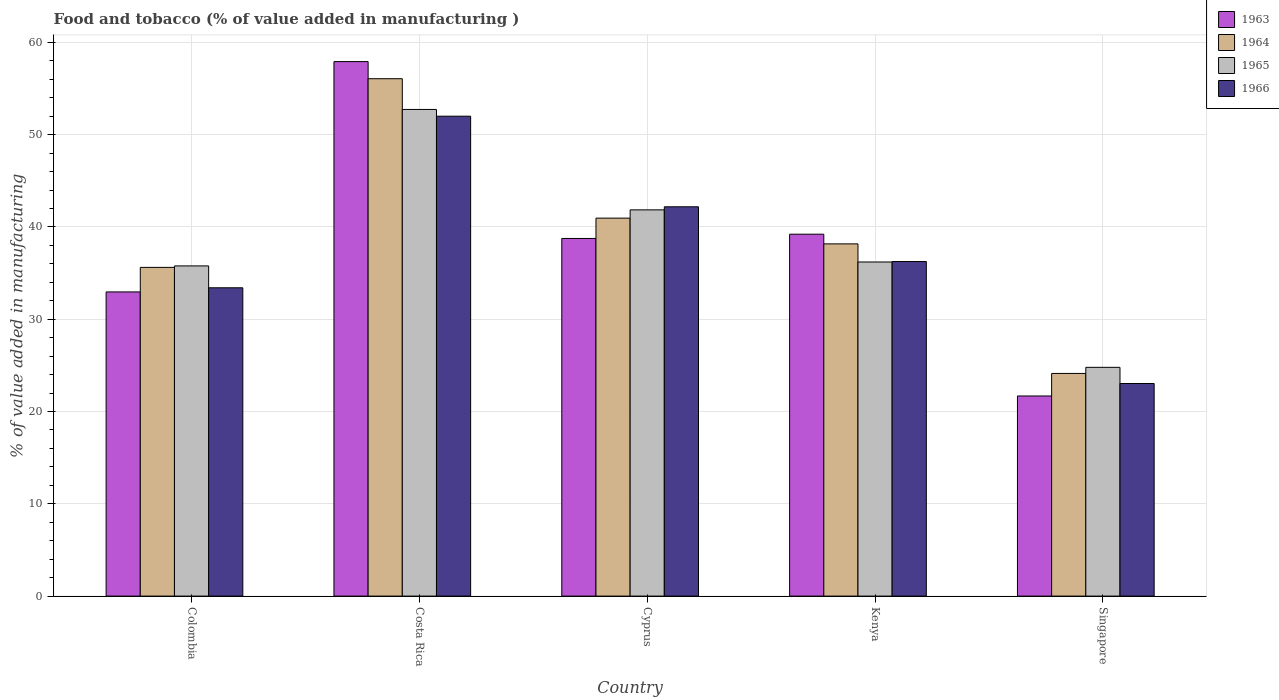How many different coloured bars are there?
Your answer should be very brief. 4. How many groups of bars are there?
Your answer should be compact. 5. Are the number of bars per tick equal to the number of legend labels?
Offer a terse response. Yes. How many bars are there on the 2nd tick from the left?
Offer a terse response. 4. What is the label of the 4th group of bars from the left?
Give a very brief answer. Kenya. In how many cases, is the number of bars for a given country not equal to the number of legend labels?
Offer a terse response. 0. What is the value added in manufacturing food and tobacco in 1963 in Singapore?
Offer a very short reply. 21.69. Across all countries, what is the maximum value added in manufacturing food and tobacco in 1964?
Ensure brevity in your answer.  56.07. Across all countries, what is the minimum value added in manufacturing food and tobacco in 1966?
Keep it short and to the point. 23.04. In which country was the value added in manufacturing food and tobacco in 1963 maximum?
Provide a succinct answer. Costa Rica. In which country was the value added in manufacturing food and tobacco in 1964 minimum?
Offer a terse response. Singapore. What is the total value added in manufacturing food and tobacco in 1966 in the graph?
Make the answer very short. 186.89. What is the difference between the value added in manufacturing food and tobacco in 1963 in Cyprus and that in Kenya?
Provide a short and direct response. -0.46. What is the difference between the value added in manufacturing food and tobacco in 1964 in Costa Rica and the value added in manufacturing food and tobacco in 1963 in Colombia?
Keep it short and to the point. 23.11. What is the average value added in manufacturing food and tobacco in 1966 per country?
Keep it short and to the point. 37.38. What is the difference between the value added in manufacturing food and tobacco of/in 1966 and value added in manufacturing food and tobacco of/in 1963 in Colombia?
Make the answer very short. 0.45. What is the ratio of the value added in manufacturing food and tobacco in 1964 in Colombia to that in Costa Rica?
Your response must be concise. 0.64. Is the value added in manufacturing food and tobacco in 1965 in Kenya less than that in Singapore?
Give a very brief answer. No. Is the difference between the value added in manufacturing food and tobacco in 1966 in Colombia and Singapore greater than the difference between the value added in manufacturing food and tobacco in 1963 in Colombia and Singapore?
Ensure brevity in your answer.  No. What is the difference between the highest and the second highest value added in manufacturing food and tobacco in 1964?
Provide a succinct answer. 15.11. What is the difference between the highest and the lowest value added in manufacturing food and tobacco in 1964?
Your answer should be compact. 31.94. In how many countries, is the value added in manufacturing food and tobacco in 1963 greater than the average value added in manufacturing food and tobacco in 1963 taken over all countries?
Ensure brevity in your answer.  3. Is the sum of the value added in manufacturing food and tobacco in 1965 in Colombia and Kenya greater than the maximum value added in manufacturing food and tobacco in 1966 across all countries?
Your answer should be very brief. Yes. Is it the case that in every country, the sum of the value added in manufacturing food and tobacco in 1966 and value added in manufacturing food and tobacco in 1963 is greater than the sum of value added in manufacturing food and tobacco in 1965 and value added in manufacturing food and tobacco in 1964?
Your response must be concise. No. What does the 4th bar from the left in Kenya represents?
Your answer should be very brief. 1966. What does the 1st bar from the right in Kenya represents?
Give a very brief answer. 1966. Is it the case that in every country, the sum of the value added in manufacturing food and tobacco in 1963 and value added in manufacturing food and tobacco in 1964 is greater than the value added in manufacturing food and tobacco in 1965?
Offer a very short reply. Yes. How many bars are there?
Keep it short and to the point. 20. Are all the bars in the graph horizontal?
Offer a very short reply. No. How many countries are there in the graph?
Offer a terse response. 5. Are the values on the major ticks of Y-axis written in scientific E-notation?
Your answer should be compact. No. Does the graph contain grids?
Ensure brevity in your answer.  Yes. How many legend labels are there?
Your answer should be compact. 4. What is the title of the graph?
Offer a terse response. Food and tobacco (% of value added in manufacturing ). Does "1962" appear as one of the legend labels in the graph?
Provide a short and direct response. No. What is the label or title of the Y-axis?
Give a very brief answer. % of value added in manufacturing. What is the % of value added in manufacturing of 1963 in Colombia?
Ensure brevity in your answer.  32.96. What is the % of value added in manufacturing of 1964 in Colombia?
Give a very brief answer. 35.62. What is the % of value added in manufacturing in 1965 in Colombia?
Make the answer very short. 35.78. What is the % of value added in manufacturing in 1966 in Colombia?
Provide a succinct answer. 33.41. What is the % of value added in manufacturing in 1963 in Costa Rica?
Offer a terse response. 57.92. What is the % of value added in manufacturing in 1964 in Costa Rica?
Keep it short and to the point. 56.07. What is the % of value added in manufacturing of 1965 in Costa Rica?
Make the answer very short. 52.73. What is the % of value added in manufacturing in 1966 in Costa Rica?
Make the answer very short. 52. What is the % of value added in manufacturing in 1963 in Cyprus?
Your answer should be very brief. 38.75. What is the % of value added in manufacturing of 1964 in Cyprus?
Your answer should be very brief. 40.96. What is the % of value added in manufacturing of 1965 in Cyprus?
Offer a very short reply. 41.85. What is the % of value added in manufacturing of 1966 in Cyprus?
Give a very brief answer. 42.19. What is the % of value added in manufacturing of 1963 in Kenya?
Your answer should be compact. 39.22. What is the % of value added in manufacturing in 1964 in Kenya?
Offer a terse response. 38.17. What is the % of value added in manufacturing in 1965 in Kenya?
Offer a very short reply. 36.2. What is the % of value added in manufacturing of 1966 in Kenya?
Your answer should be compact. 36.25. What is the % of value added in manufacturing of 1963 in Singapore?
Keep it short and to the point. 21.69. What is the % of value added in manufacturing of 1964 in Singapore?
Your answer should be compact. 24.13. What is the % of value added in manufacturing in 1965 in Singapore?
Give a very brief answer. 24.79. What is the % of value added in manufacturing of 1966 in Singapore?
Offer a very short reply. 23.04. Across all countries, what is the maximum % of value added in manufacturing in 1963?
Your answer should be compact. 57.92. Across all countries, what is the maximum % of value added in manufacturing in 1964?
Offer a terse response. 56.07. Across all countries, what is the maximum % of value added in manufacturing in 1965?
Keep it short and to the point. 52.73. Across all countries, what is the maximum % of value added in manufacturing of 1966?
Your answer should be very brief. 52. Across all countries, what is the minimum % of value added in manufacturing of 1963?
Offer a terse response. 21.69. Across all countries, what is the minimum % of value added in manufacturing in 1964?
Your answer should be compact. 24.13. Across all countries, what is the minimum % of value added in manufacturing of 1965?
Give a very brief answer. 24.79. Across all countries, what is the minimum % of value added in manufacturing in 1966?
Offer a terse response. 23.04. What is the total % of value added in manufacturing of 1963 in the graph?
Keep it short and to the point. 190.54. What is the total % of value added in manufacturing of 1964 in the graph?
Ensure brevity in your answer.  194.94. What is the total % of value added in manufacturing in 1965 in the graph?
Provide a succinct answer. 191.36. What is the total % of value added in manufacturing in 1966 in the graph?
Give a very brief answer. 186.89. What is the difference between the % of value added in manufacturing of 1963 in Colombia and that in Costa Rica?
Your answer should be compact. -24.96. What is the difference between the % of value added in manufacturing in 1964 in Colombia and that in Costa Rica?
Your response must be concise. -20.45. What is the difference between the % of value added in manufacturing in 1965 in Colombia and that in Costa Rica?
Your response must be concise. -16.95. What is the difference between the % of value added in manufacturing in 1966 in Colombia and that in Costa Rica?
Provide a short and direct response. -18.59. What is the difference between the % of value added in manufacturing of 1963 in Colombia and that in Cyprus?
Keep it short and to the point. -5.79. What is the difference between the % of value added in manufacturing of 1964 in Colombia and that in Cyprus?
Your answer should be compact. -5.34. What is the difference between the % of value added in manufacturing in 1965 in Colombia and that in Cyprus?
Ensure brevity in your answer.  -6.07. What is the difference between the % of value added in manufacturing in 1966 in Colombia and that in Cyprus?
Offer a terse response. -8.78. What is the difference between the % of value added in manufacturing in 1963 in Colombia and that in Kenya?
Ensure brevity in your answer.  -6.26. What is the difference between the % of value added in manufacturing in 1964 in Colombia and that in Kenya?
Provide a short and direct response. -2.55. What is the difference between the % of value added in manufacturing of 1965 in Colombia and that in Kenya?
Keep it short and to the point. -0.42. What is the difference between the % of value added in manufacturing of 1966 in Colombia and that in Kenya?
Provide a short and direct response. -2.84. What is the difference between the % of value added in manufacturing of 1963 in Colombia and that in Singapore?
Provide a short and direct response. 11.27. What is the difference between the % of value added in manufacturing in 1964 in Colombia and that in Singapore?
Make the answer very short. 11.49. What is the difference between the % of value added in manufacturing of 1965 in Colombia and that in Singapore?
Your answer should be compact. 10.99. What is the difference between the % of value added in manufacturing of 1966 in Colombia and that in Singapore?
Offer a terse response. 10.37. What is the difference between the % of value added in manufacturing in 1963 in Costa Rica and that in Cyprus?
Provide a short and direct response. 19.17. What is the difference between the % of value added in manufacturing in 1964 in Costa Rica and that in Cyprus?
Keep it short and to the point. 15.11. What is the difference between the % of value added in manufacturing in 1965 in Costa Rica and that in Cyprus?
Provide a short and direct response. 10.88. What is the difference between the % of value added in manufacturing of 1966 in Costa Rica and that in Cyprus?
Ensure brevity in your answer.  9.82. What is the difference between the % of value added in manufacturing in 1963 in Costa Rica and that in Kenya?
Your answer should be very brief. 18.7. What is the difference between the % of value added in manufacturing of 1964 in Costa Rica and that in Kenya?
Your answer should be very brief. 17.9. What is the difference between the % of value added in manufacturing of 1965 in Costa Rica and that in Kenya?
Your answer should be very brief. 16.53. What is the difference between the % of value added in manufacturing of 1966 in Costa Rica and that in Kenya?
Provide a short and direct response. 15.75. What is the difference between the % of value added in manufacturing of 1963 in Costa Rica and that in Singapore?
Provide a short and direct response. 36.23. What is the difference between the % of value added in manufacturing in 1964 in Costa Rica and that in Singapore?
Ensure brevity in your answer.  31.94. What is the difference between the % of value added in manufacturing in 1965 in Costa Rica and that in Singapore?
Your response must be concise. 27.94. What is the difference between the % of value added in manufacturing of 1966 in Costa Rica and that in Singapore?
Provide a short and direct response. 28.97. What is the difference between the % of value added in manufacturing in 1963 in Cyprus and that in Kenya?
Your answer should be very brief. -0.46. What is the difference between the % of value added in manufacturing in 1964 in Cyprus and that in Kenya?
Give a very brief answer. 2.79. What is the difference between the % of value added in manufacturing of 1965 in Cyprus and that in Kenya?
Offer a very short reply. 5.65. What is the difference between the % of value added in manufacturing in 1966 in Cyprus and that in Kenya?
Offer a terse response. 5.93. What is the difference between the % of value added in manufacturing in 1963 in Cyprus and that in Singapore?
Give a very brief answer. 17.07. What is the difference between the % of value added in manufacturing of 1964 in Cyprus and that in Singapore?
Provide a succinct answer. 16.83. What is the difference between the % of value added in manufacturing in 1965 in Cyprus and that in Singapore?
Your answer should be compact. 17.06. What is the difference between the % of value added in manufacturing of 1966 in Cyprus and that in Singapore?
Keep it short and to the point. 19.15. What is the difference between the % of value added in manufacturing in 1963 in Kenya and that in Singapore?
Make the answer very short. 17.53. What is the difference between the % of value added in manufacturing of 1964 in Kenya and that in Singapore?
Offer a very short reply. 14.04. What is the difference between the % of value added in manufacturing of 1965 in Kenya and that in Singapore?
Give a very brief answer. 11.41. What is the difference between the % of value added in manufacturing in 1966 in Kenya and that in Singapore?
Provide a short and direct response. 13.22. What is the difference between the % of value added in manufacturing of 1963 in Colombia and the % of value added in manufacturing of 1964 in Costa Rica?
Your answer should be compact. -23.11. What is the difference between the % of value added in manufacturing of 1963 in Colombia and the % of value added in manufacturing of 1965 in Costa Rica?
Provide a succinct answer. -19.77. What is the difference between the % of value added in manufacturing of 1963 in Colombia and the % of value added in manufacturing of 1966 in Costa Rica?
Your answer should be very brief. -19.04. What is the difference between the % of value added in manufacturing of 1964 in Colombia and the % of value added in manufacturing of 1965 in Costa Rica?
Offer a very short reply. -17.11. What is the difference between the % of value added in manufacturing in 1964 in Colombia and the % of value added in manufacturing in 1966 in Costa Rica?
Provide a succinct answer. -16.38. What is the difference between the % of value added in manufacturing of 1965 in Colombia and the % of value added in manufacturing of 1966 in Costa Rica?
Offer a very short reply. -16.22. What is the difference between the % of value added in manufacturing in 1963 in Colombia and the % of value added in manufacturing in 1964 in Cyprus?
Provide a succinct answer. -8. What is the difference between the % of value added in manufacturing in 1963 in Colombia and the % of value added in manufacturing in 1965 in Cyprus?
Give a very brief answer. -8.89. What is the difference between the % of value added in manufacturing in 1963 in Colombia and the % of value added in manufacturing in 1966 in Cyprus?
Your answer should be compact. -9.23. What is the difference between the % of value added in manufacturing of 1964 in Colombia and the % of value added in manufacturing of 1965 in Cyprus?
Offer a very short reply. -6.23. What is the difference between the % of value added in manufacturing in 1964 in Colombia and the % of value added in manufacturing in 1966 in Cyprus?
Make the answer very short. -6.57. What is the difference between the % of value added in manufacturing of 1965 in Colombia and the % of value added in manufacturing of 1966 in Cyprus?
Give a very brief answer. -6.41. What is the difference between the % of value added in manufacturing of 1963 in Colombia and the % of value added in manufacturing of 1964 in Kenya?
Your response must be concise. -5.21. What is the difference between the % of value added in manufacturing of 1963 in Colombia and the % of value added in manufacturing of 1965 in Kenya?
Your answer should be very brief. -3.24. What is the difference between the % of value added in manufacturing of 1963 in Colombia and the % of value added in manufacturing of 1966 in Kenya?
Your response must be concise. -3.29. What is the difference between the % of value added in manufacturing in 1964 in Colombia and the % of value added in manufacturing in 1965 in Kenya?
Provide a short and direct response. -0.58. What is the difference between the % of value added in manufacturing of 1964 in Colombia and the % of value added in manufacturing of 1966 in Kenya?
Ensure brevity in your answer.  -0.63. What is the difference between the % of value added in manufacturing in 1965 in Colombia and the % of value added in manufacturing in 1966 in Kenya?
Your response must be concise. -0.47. What is the difference between the % of value added in manufacturing in 1963 in Colombia and the % of value added in manufacturing in 1964 in Singapore?
Your response must be concise. 8.83. What is the difference between the % of value added in manufacturing in 1963 in Colombia and the % of value added in manufacturing in 1965 in Singapore?
Offer a very short reply. 8.17. What is the difference between the % of value added in manufacturing in 1963 in Colombia and the % of value added in manufacturing in 1966 in Singapore?
Ensure brevity in your answer.  9.92. What is the difference between the % of value added in manufacturing in 1964 in Colombia and the % of value added in manufacturing in 1965 in Singapore?
Provide a short and direct response. 10.83. What is the difference between the % of value added in manufacturing in 1964 in Colombia and the % of value added in manufacturing in 1966 in Singapore?
Ensure brevity in your answer.  12.58. What is the difference between the % of value added in manufacturing in 1965 in Colombia and the % of value added in manufacturing in 1966 in Singapore?
Provide a succinct answer. 12.74. What is the difference between the % of value added in manufacturing of 1963 in Costa Rica and the % of value added in manufacturing of 1964 in Cyprus?
Offer a terse response. 16.96. What is the difference between the % of value added in manufacturing of 1963 in Costa Rica and the % of value added in manufacturing of 1965 in Cyprus?
Provide a succinct answer. 16.07. What is the difference between the % of value added in manufacturing of 1963 in Costa Rica and the % of value added in manufacturing of 1966 in Cyprus?
Give a very brief answer. 15.73. What is the difference between the % of value added in manufacturing of 1964 in Costa Rica and the % of value added in manufacturing of 1965 in Cyprus?
Provide a short and direct response. 14.21. What is the difference between the % of value added in manufacturing in 1964 in Costa Rica and the % of value added in manufacturing in 1966 in Cyprus?
Offer a very short reply. 13.88. What is the difference between the % of value added in manufacturing in 1965 in Costa Rica and the % of value added in manufacturing in 1966 in Cyprus?
Make the answer very short. 10.55. What is the difference between the % of value added in manufacturing of 1963 in Costa Rica and the % of value added in manufacturing of 1964 in Kenya?
Offer a terse response. 19.75. What is the difference between the % of value added in manufacturing in 1963 in Costa Rica and the % of value added in manufacturing in 1965 in Kenya?
Provide a short and direct response. 21.72. What is the difference between the % of value added in manufacturing in 1963 in Costa Rica and the % of value added in manufacturing in 1966 in Kenya?
Your answer should be compact. 21.67. What is the difference between the % of value added in manufacturing in 1964 in Costa Rica and the % of value added in manufacturing in 1965 in Kenya?
Offer a very short reply. 19.86. What is the difference between the % of value added in manufacturing in 1964 in Costa Rica and the % of value added in manufacturing in 1966 in Kenya?
Ensure brevity in your answer.  19.81. What is the difference between the % of value added in manufacturing in 1965 in Costa Rica and the % of value added in manufacturing in 1966 in Kenya?
Provide a succinct answer. 16.48. What is the difference between the % of value added in manufacturing of 1963 in Costa Rica and the % of value added in manufacturing of 1964 in Singapore?
Provide a succinct answer. 33.79. What is the difference between the % of value added in manufacturing in 1963 in Costa Rica and the % of value added in manufacturing in 1965 in Singapore?
Provide a succinct answer. 33.13. What is the difference between the % of value added in manufacturing in 1963 in Costa Rica and the % of value added in manufacturing in 1966 in Singapore?
Keep it short and to the point. 34.88. What is the difference between the % of value added in manufacturing of 1964 in Costa Rica and the % of value added in manufacturing of 1965 in Singapore?
Ensure brevity in your answer.  31.28. What is the difference between the % of value added in manufacturing in 1964 in Costa Rica and the % of value added in manufacturing in 1966 in Singapore?
Your response must be concise. 33.03. What is the difference between the % of value added in manufacturing in 1965 in Costa Rica and the % of value added in manufacturing in 1966 in Singapore?
Your answer should be very brief. 29.7. What is the difference between the % of value added in manufacturing of 1963 in Cyprus and the % of value added in manufacturing of 1964 in Kenya?
Offer a very short reply. 0.59. What is the difference between the % of value added in manufacturing in 1963 in Cyprus and the % of value added in manufacturing in 1965 in Kenya?
Your answer should be compact. 2.55. What is the difference between the % of value added in manufacturing in 1963 in Cyprus and the % of value added in manufacturing in 1966 in Kenya?
Make the answer very short. 2.5. What is the difference between the % of value added in manufacturing in 1964 in Cyprus and the % of value added in manufacturing in 1965 in Kenya?
Ensure brevity in your answer.  4.75. What is the difference between the % of value added in manufacturing of 1964 in Cyprus and the % of value added in manufacturing of 1966 in Kenya?
Offer a very short reply. 4.7. What is the difference between the % of value added in manufacturing in 1965 in Cyprus and the % of value added in manufacturing in 1966 in Kenya?
Provide a short and direct response. 5.6. What is the difference between the % of value added in manufacturing in 1963 in Cyprus and the % of value added in manufacturing in 1964 in Singapore?
Your answer should be compact. 14.63. What is the difference between the % of value added in manufacturing in 1963 in Cyprus and the % of value added in manufacturing in 1965 in Singapore?
Your answer should be very brief. 13.96. What is the difference between the % of value added in manufacturing in 1963 in Cyprus and the % of value added in manufacturing in 1966 in Singapore?
Offer a very short reply. 15.72. What is the difference between the % of value added in manufacturing of 1964 in Cyprus and the % of value added in manufacturing of 1965 in Singapore?
Ensure brevity in your answer.  16.17. What is the difference between the % of value added in manufacturing in 1964 in Cyprus and the % of value added in manufacturing in 1966 in Singapore?
Your answer should be compact. 17.92. What is the difference between the % of value added in manufacturing of 1965 in Cyprus and the % of value added in manufacturing of 1966 in Singapore?
Make the answer very short. 18.82. What is the difference between the % of value added in manufacturing in 1963 in Kenya and the % of value added in manufacturing in 1964 in Singapore?
Give a very brief answer. 15.09. What is the difference between the % of value added in manufacturing of 1963 in Kenya and the % of value added in manufacturing of 1965 in Singapore?
Keep it short and to the point. 14.43. What is the difference between the % of value added in manufacturing in 1963 in Kenya and the % of value added in manufacturing in 1966 in Singapore?
Make the answer very short. 16.18. What is the difference between the % of value added in manufacturing in 1964 in Kenya and the % of value added in manufacturing in 1965 in Singapore?
Your response must be concise. 13.38. What is the difference between the % of value added in manufacturing in 1964 in Kenya and the % of value added in manufacturing in 1966 in Singapore?
Provide a short and direct response. 15.13. What is the difference between the % of value added in manufacturing in 1965 in Kenya and the % of value added in manufacturing in 1966 in Singapore?
Provide a short and direct response. 13.17. What is the average % of value added in manufacturing in 1963 per country?
Offer a very short reply. 38.11. What is the average % of value added in manufacturing in 1964 per country?
Your response must be concise. 38.99. What is the average % of value added in manufacturing of 1965 per country?
Make the answer very short. 38.27. What is the average % of value added in manufacturing of 1966 per country?
Keep it short and to the point. 37.38. What is the difference between the % of value added in manufacturing in 1963 and % of value added in manufacturing in 1964 in Colombia?
Keep it short and to the point. -2.66. What is the difference between the % of value added in manufacturing of 1963 and % of value added in manufacturing of 1965 in Colombia?
Provide a short and direct response. -2.82. What is the difference between the % of value added in manufacturing of 1963 and % of value added in manufacturing of 1966 in Colombia?
Make the answer very short. -0.45. What is the difference between the % of value added in manufacturing in 1964 and % of value added in manufacturing in 1965 in Colombia?
Your answer should be compact. -0.16. What is the difference between the % of value added in manufacturing in 1964 and % of value added in manufacturing in 1966 in Colombia?
Your response must be concise. 2.21. What is the difference between the % of value added in manufacturing of 1965 and % of value added in manufacturing of 1966 in Colombia?
Make the answer very short. 2.37. What is the difference between the % of value added in manufacturing of 1963 and % of value added in manufacturing of 1964 in Costa Rica?
Make the answer very short. 1.85. What is the difference between the % of value added in manufacturing of 1963 and % of value added in manufacturing of 1965 in Costa Rica?
Provide a succinct answer. 5.19. What is the difference between the % of value added in manufacturing in 1963 and % of value added in manufacturing in 1966 in Costa Rica?
Provide a short and direct response. 5.92. What is the difference between the % of value added in manufacturing of 1964 and % of value added in manufacturing of 1965 in Costa Rica?
Provide a short and direct response. 3.33. What is the difference between the % of value added in manufacturing of 1964 and % of value added in manufacturing of 1966 in Costa Rica?
Your answer should be very brief. 4.06. What is the difference between the % of value added in manufacturing of 1965 and % of value added in manufacturing of 1966 in Costa Rica?
Offer a terse response. 0.73. What is the difference between the % of value added in manufacturing of 1963 and % of value added in manufacturing of 1964 in Cyprus?
Your answer should be very brief. -2.2. What is the difference between the % of value added in manufacturing of 1963 and % of value added in manufacturing of 1965 in Cyprus?
Provide a succinct answer. -3.1. What is the difference between the % of value added in manufacturing of 1963 and % of value added in manufacturing of 1966 in Cyprus?
Your answer should be compact. -3.43. What is the difference between the % of value added in manufacturing of 1964 and % of value added in manufacturing of 1965 in Cyprus?
Your answer should be very brief. -0.9. What is the difference between the % of value added in manufacturing in 1964 and % of value added in manufacturing in 1966 in Cyprus?
Offer a very short reply. -1.23. What is the difference between the % of value added in manufacturing in 1965 and % of value added in manufacturing in 1966 in Cyprus?
Give a very brief answer. -0.33. What is the difference between the % of value added in manufacturing of 1963 and % of value added in manufacturing of 1964 in Kenya?
Offer a terse response. 1.05. What is the difference between the % of value added in manufacturing of 1963 and % of value added in manufacturing of 1965 in Kenya?
Give a very brief answer. 3.01. What is the difference between the % of value added in manufacturing of 1963 and % of value added in manufacturing of 1966 in Kenya?
Make the answer very short. 2.96. What is the difference between the % of value added in manufacturing of 1964 and % of value added in manufacturing of 1965 in Kenya?
Your answer should be very brief. 1.96. What is the difference between the % of value added in manufacturing of 1964 and % of value added in manufacturing of 1966 in Kenya?
Ensure brevity in your answer.  1.91. What is the difference between the % of value added in manufacturing of 1965 and % of value added in manufacturing of 1966 in Kenya?
Provide a succinct answer. -0.05. What is the difference between the % of value added in manufacturing of 1963 and % of value added in manufacturing of 1964 in Singapore?
Your answer should be very brief. -2.44. What is the difference between the % of value added in manufacturing of 1963 and % of value added in manufacturing of 1965 in Singapore?
Ensure brevity in your answer.  -3.1. What is the difference between the % of value added in manufacturing in 1963 and % of value added in manufacturing in 1966 in Singapore?
Your answer should be compact. -1.35. What is the difference between the % of value added in manufacturing in 1964 and % of value added in manufacturing in 1965 in Singapore?
Ensure brevity in your answer.  -0.66. What is the difference between the % of value added in manufacturing of 1964 and % of value added in manufacturing of 1966 in Singapore?
Make the answer very short. 1.09. What is the difference between the % of value added in manufacturing of 1965 and % of value added in manufacturing of 1966 in Singapore?
Make the answer very short. 1.75. What is the ratio of the % of value added in manufacturing of 1963 in Colombia to that in Costa Rica?
Your answer should be compact. 0.57. What is the ratio of the % of value added in manufacturing in 1964 in Colombia to that in Costa Rica?
Give a very brief answer. 0.64. What is the ratio of the % of value added in manufacturing of 1965 in Colombia to that in Costa Rica?
Your response must be concise. 0.68. What is the ratio of the % of value added in manufacturing in 1966 in Colombia to that in Costa Rica?
Your answer should be compact. 0.64. What is the ratio of the % of value added in manufacturing of 1963 in Colombia to that in Cyprus?
Your response must be concise. 0.85. What is the ratio of the % of value added in manufacturing in 1964 in Colombia to that in Cyprus?
Provide a short and direct response. 0.87. What is the ratio of the % of value added in manufacturing in 1965 in Colombia to that in Cyprus?
Ensure brevity in your answer.  0.85. What is the ratio of the % of value added in manufacturing of 1966 in Colombia to that in Cyprus?
Your response must be concise. 0.79. What is the ratio of the % of value added in manufacturing of 1963 in Colombia to that in Kenya?
Give a very brief answer. 0.84. What is the ratio of the % of value added in manufacturing in 1964 in Colombia to that in Kenya?
Give a very brief answer. 0.93. What is the ratio of the % of value added in manufacturing in 1965 in Colombia to that in Kenya?
Ensure brevity in your answer.  0.99. What is the ratio of the % of value added in manufacturing in 1966 in Colombia to that in Kenya?
Your answer should be compact. 0.92. What is the ratio of the % of value added in manufacturing in 1963 in Colombia to that in Singapore?
Keep it short and to the point. 1.52. What is the ratio of the % of value added in manufacturing of 1964 in Colombia to that in Singapore?
Your answer should be very brief. 1.48. What is the ratio of the % of value added in manufacturing in 1965 in Colombia to that in Singapore?
Offer a terse response. 1.44. What is the ratio of the % of value added in manufacturing in 1966 in Colombia to that in Singapore?
Provide a short and direct response. 1.45. What is the ratio of the % of value added in manufacturing in 1963 in Costa Rica to that in Cyprus?
Provide a short and direct response. 1.49. What is the ratio of the % of value added in manufacturing in 1964 in Costa Rica to that in Cyprus?
Your answer should be very brief. 1.37. What is the ratio of the % of value added in manufacturing in 1965 in Costa Rica to that in Cyprus?
Give a very brief answer. 1.26. What is the ratio of the % of value added in manufacturing of 1966 in Costa Rica to that in Cyprus?
Your answer should be compact. 1.23. What is the ratio of the % of value added in manufacturing of 1963 in Costa Rica to that in Kenya?
Your response must be concise. 1.48. What is the ratio of the % of value added in manufacturing of 1964 in Costa Rica to that in Kenya?
Provide a succinct answer. 1.47. What is the ratio of the % of value added in manufacturing in 1965 in Costa Rica to that in Kenya?
Keep it short and to the point. 1.46. What is the ratio of the % of value added in manufacturing in 1966 in Costa Rica to that in Kenya?
Provide a succinct answer. 1.43. What is the ratio of the % of value added in manufacturing of 1963 in Costa Rica to that in Singapore?
Make the answer very short. 2.67. What is the ratio of the % of value added in manufacturing in 1964 in Costa Rica to that in Singapore?
Make the answer very short. 2.32. What is the ratio of the % of value added in manufacturing in 1965 in Costa Rica to that in Singapore?
Your answer should be compact. 2.13. What is the ratio of the % of value added in manufacturing in 1966 in Costa Rica to that in Singapore?
Keep it short and to the point. 2.26. What is the ratio of the % of value added in manufacturing of 1963 in Cyprus to that in Kenya?
Offer a very short reply. 0.99. What is the ratio of the % of value added in manufacturing of 1964 in Cyprus to that in Kenya?
Your answer should be very brief. 1.07. What is the ratio of the % of value added in manufacturing in 1965 in Cyprus to that in Kenya?
Your answer should be compact. 1.16. What is the ratio of the % of value added in manufacturing of 1966 in Cyprus to that in Kenya?
Give a very brief answer. 1.16. What is the ratio of the % of value added in manufacturing in 1963 in Cyprus to that in Singapore?
Give a very brief answer. 1.79. What is the ratio of the % of value added in manufacturing of 1964 in Cyprus to that in Singapore?
Give a very brief answer. 1.7. What is the ratio of the % of value added in manufacturing of 1965 in Cyprus to that in Singapore?
Offer a terse response. 1.69. What is the ratio of the % of value added in manufacturing of 1966 in Cyprus to that in Singapore?
Keep it short and to the point. 1.83. What is the ratio of the % of value added in manufacturing in 1963 in Kenya to that in Singapore?
Provide a succinct answer. 1.81. What is the ratio of the % of value added in manufacturing in 1964 in Kenya to that in Singapore?
Ensure brevity in your answer.  1.58. What is the ratio of the % of value added in manufacturing in 1965 in Kenya to that in Singapore?
Your response must be concise. 1.46. What is the ratio of the % of value added in manufacturing of 1966 in Kenya to that in Singapore?
Ensure brevity in your answer.  1.57. What is the difference between the highest and the second highest % of value added in manufacturing of 1963?
Your response must be concise. 18.7. What is the difference between the highest and the second highest % of value added in manufacturing of 1964?
Give a very brief answer. 15.11. What is the difference between the highest and the second highest % of value added in manufacturing of 1965?
Ensure brevity in your answer.  10.88. What is the difference between the highest and the second highest % of value added in manufacturing of 1966?
Your answer should be very brief. 9.82. What is the difference between the highest and the lowest % of value added in manufacturing in 1963?
Your answer should be compact. 36.23. What is the difference between the highest and the lowest % of value added in manufacturing of 1964?
Provide a short and direct response. 31.94. What is the difference between the highest and the lowest % of value added in manufacturing of 1965?
Your response must be concise. 27.94. What is the difference between the highest and the lowest % of value added in manufacturing of 1966?
Offer a terse response. 28.97. 